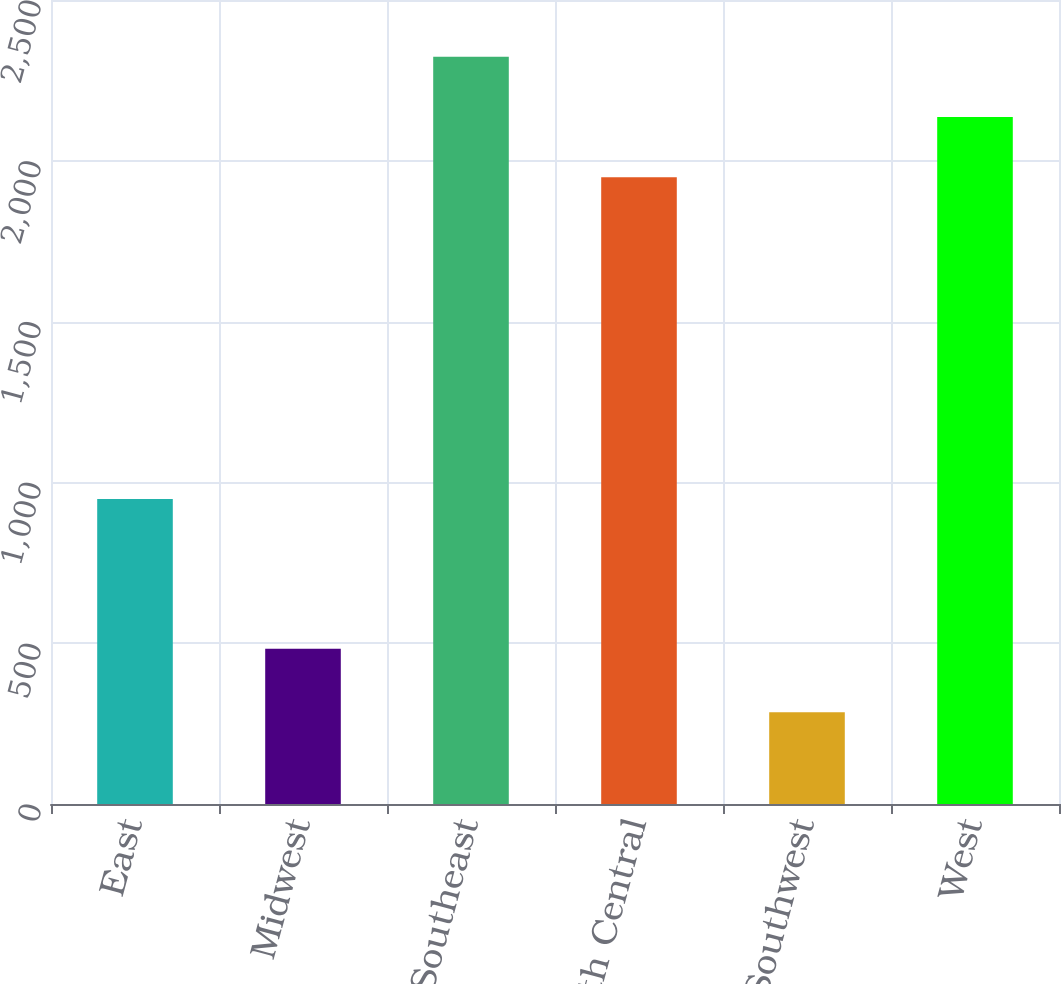<chart> <loc_0><loc_0><loc_500><loc_500><bar_chart><fcel>East<fcel>Midwest<fcel>Southeast<fcel>South Central<fcel>Southwest<fcel>West<nl><fcel>948<fcel>483<fcel>2323.16<fcel>1948.6<fcel>285.2<fcel>2135.88<nl></chart> 